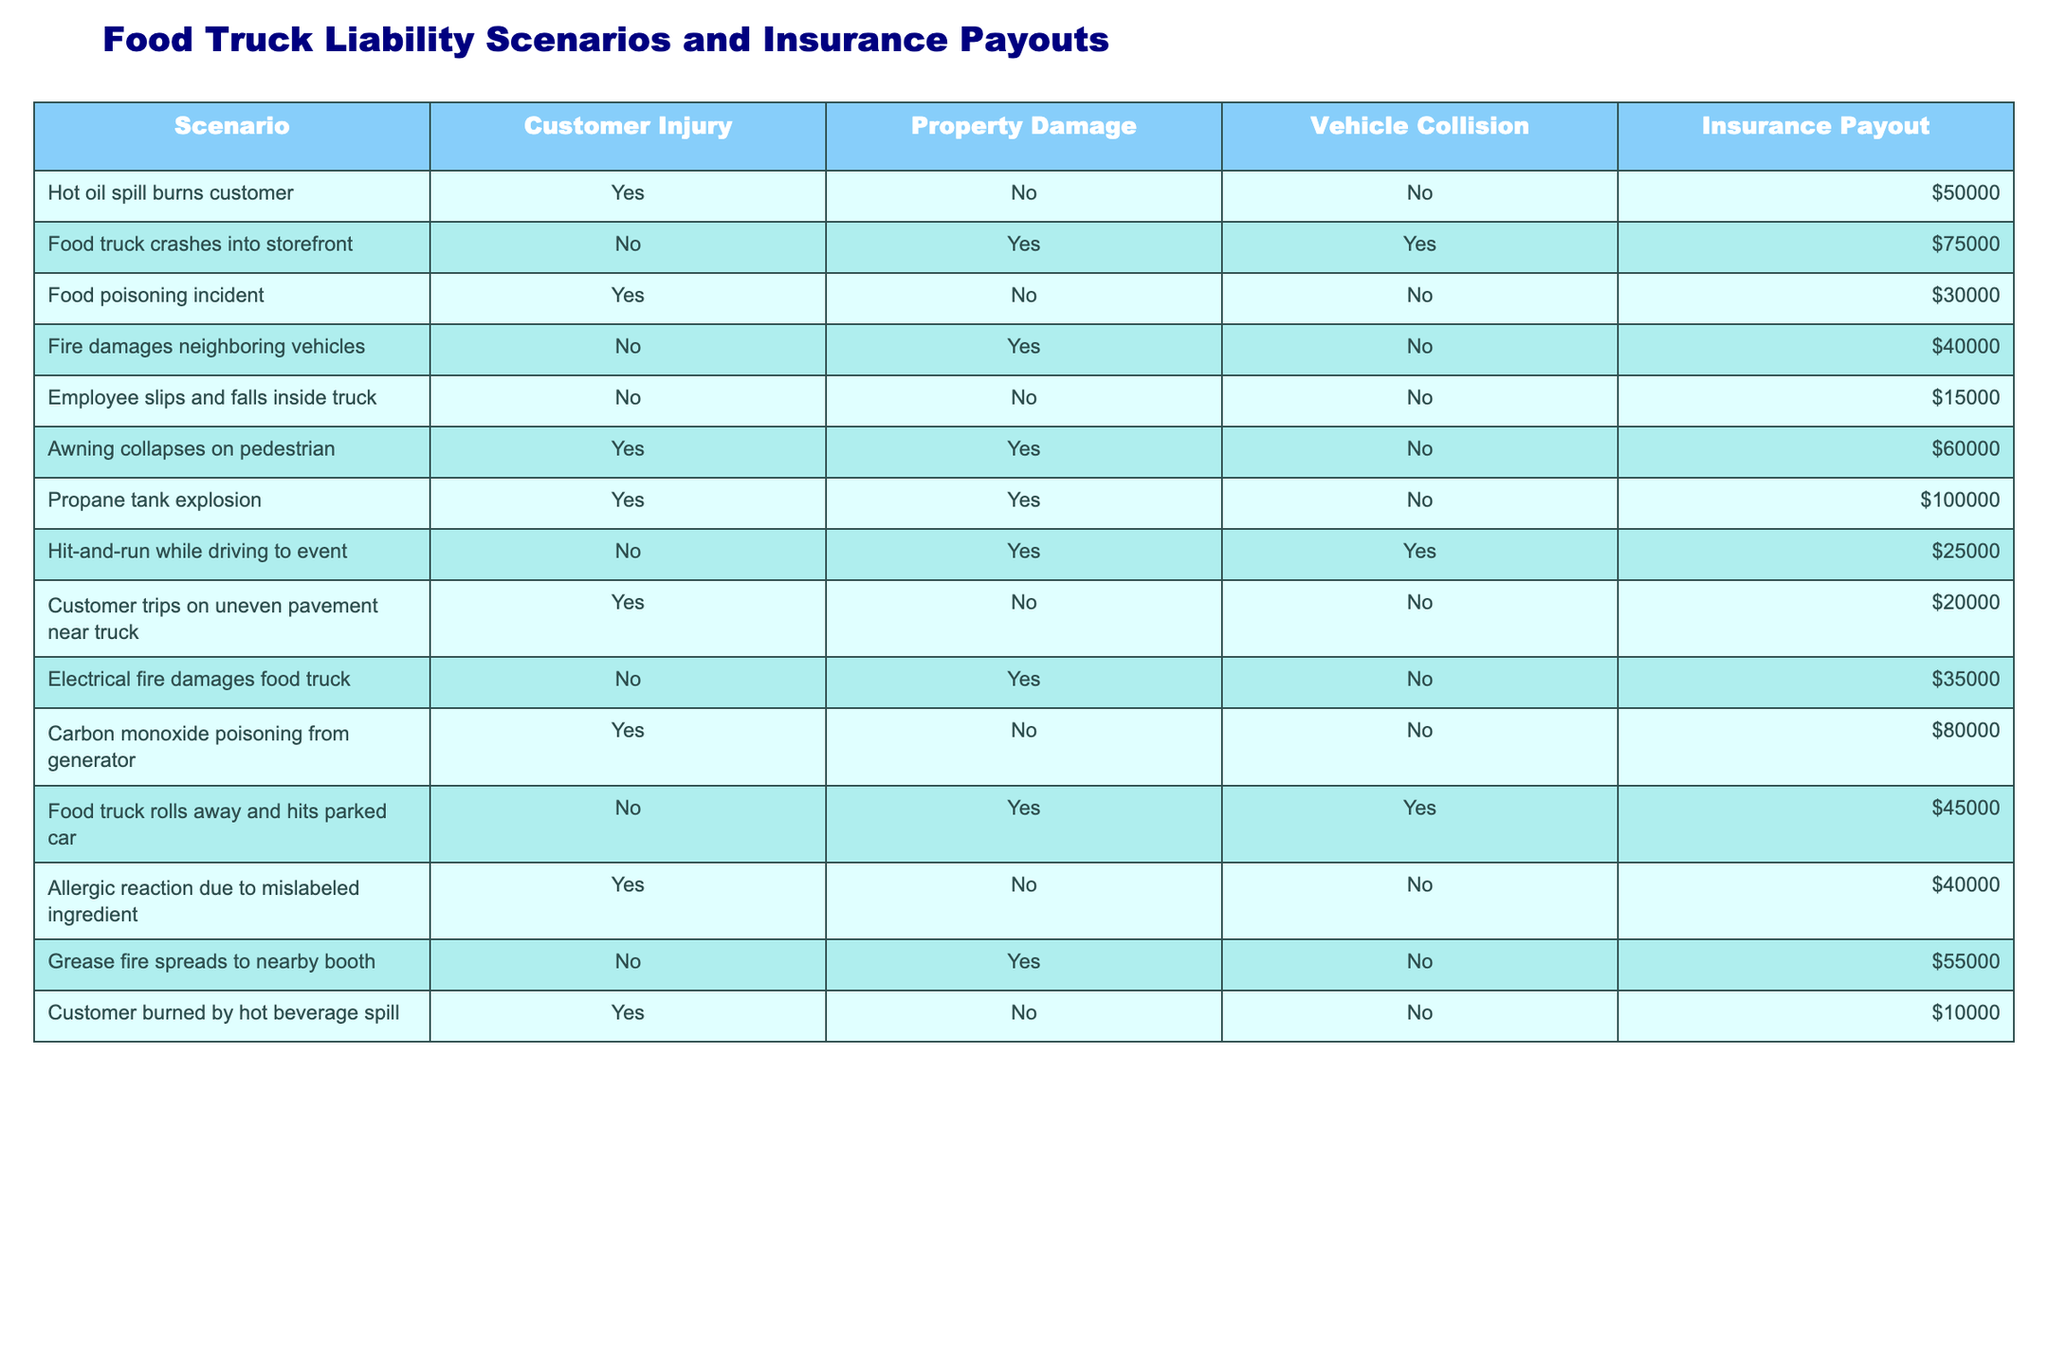What is the insurance payout for a customer injured by a hot oil spill? The table lists the scenario of a hot oil spill burning a customer, which has an insurance payout of $50,000. Therefore, the payout amount can be directly retrieved from the table.
Answer: $50,000 In how many scenarios is there property damage? By examining the table, the relevant scenarios where property damage occurred are: food truck crashes into storefront, fire damages neighboring vehicles, food truck rolls away and hits parked car, and a grease fire spreads to a nearby booth. There are a total of four scenarios that indicate property damage.
Answer: 4 What is the total insurance payout for incidents involving customer injuries? Scanning the table, I sum the payouts for the scenarios where there was customer injury: hot oil spill ($50,000) + food poisoning ($30,000) + awning collapse ($60,000) + propane explosion ($100,000) + carbon monoxide poisoning ($80,000) + allergic reaction ($40,000) + customer burned by hot beverage spill ($10,000) = $380,000. The addition of these payouts gives us the total for incidents involving customer injuries.
Answer: $380,000 Is there a scenario where both customer injury and property damage occurred? Yes, in the table, the scenario of the awning collapsing on a pedestrian shows both customer injury and property damage, confirming the existence of such an incident in the table.
Answer: Yes What is the highest insurance payout listed in the table? I review the payouts column in the table and find that the highest insurance payout is from the propane tank explosion, which amounts to $100,000. This is the maximum value when comparing all the payouts listed.
Answer: $100,000 What was the insurance payout for the food truck crashing into a storefront? Checking the table, the scenario for the food truck crashing into a storefront shows an insurance payout of $75,000. This is a direct retrieval of information from the table.
Answer: $75,000 How many scenarios resulted in no payouts at all? Analyzing the table, the only incident without an insurance payout is the employee slipping and falling inside the truck, which had a payout of $15,000. Hence, there are no scenarios resulting in no payouts as the minimum payout recorded is $10,000.
Answer: 0 Which scenario has the same payout as customer trips on uneven pavement near truck? The payout for the customer tripping scenario is $20,000. Looking through the table, I find that there are no other scenarios listed that have the same payout amount. Therefore, there is no matching scenario with the same insurance payout as that incident.
Answer: None 